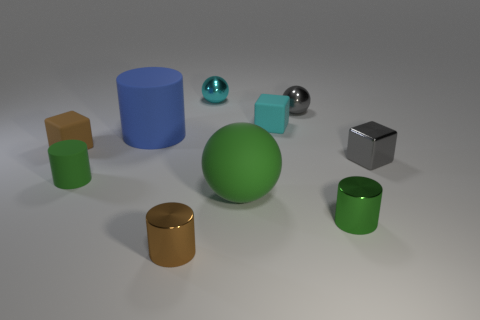Subtract all large green rubber spheres. How many spheres are left? 2 Subtract all green balls. How many green cylinders are left? 2 Subtract all blue cylinders. How many cylinders are left? 3 Subtract all yellow cylinders. Subtract all cyan blocks. How many cylinders are left? 4 Subtract all cylinders. How many objects are left? 6 Add 2 small shiny cylinders. How many small shiny cylinders exist? 4 Subtract 1 cyan cubes. How many objects are left? 9 Subtract all big red matte cylinders. Subtract all tiny cyan spheres. How many objects are left? 9 Add 6 small green rubber objects. How many small green rubber objects are left? 7 